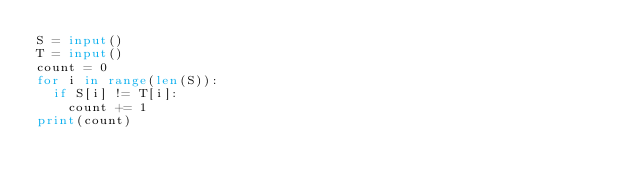<code> <loc_0><loc_0><loc_500><loc_500><_Python_>S = input()
T = input()
count = 0
for i in range(len(S)):
  if S[i] != T[i]:
    count += 1
print(count)</code> 